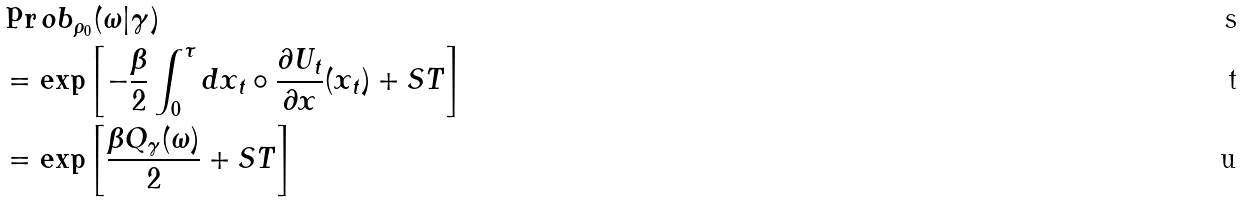Convert formula to latex. <formula><loc_0><loc_0><loc_500><loc_500>& \Pr o b _ { \rho _ { 0 } } ( \omega | \gamma ) \\ & = \exp \left [ - \frac { \beta } { 2 } \int _ { 0 } ^ { \tau } d x _ { t } \circ \frac { \partial U _ { t } } { \partial x } ( x _ { t } ) + S T \right ] \\ & = \exp \left [ \frac { \beta Q _ { \gamma } ( \omega ) } { 2 } + S T \right ]</formula> 